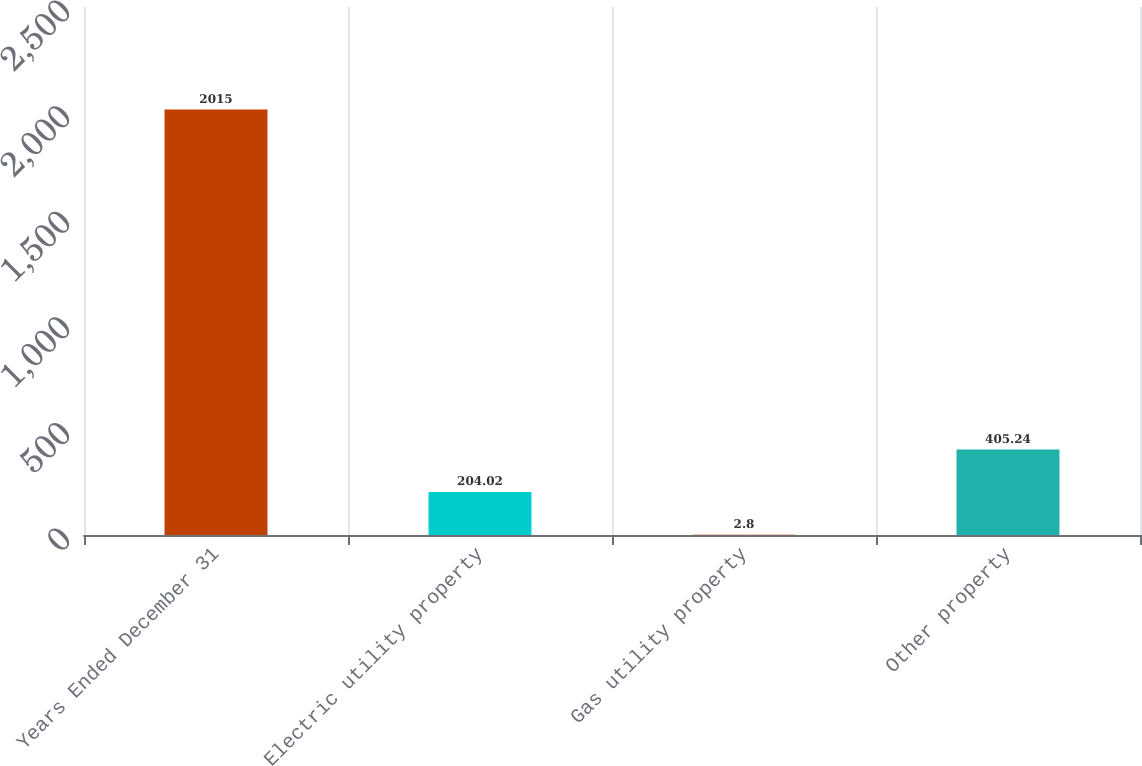<chart> <loc_0><loc_0><loc_500><loc_500><bar_chart><fcel>Years Ended December 31<fcel>Electric utility property<fcel>Gas utility property<fcel>Other property<nl><fcel>2015<fcel>204.02<fcel>2.8<fcel>405.24<nl></chart> 